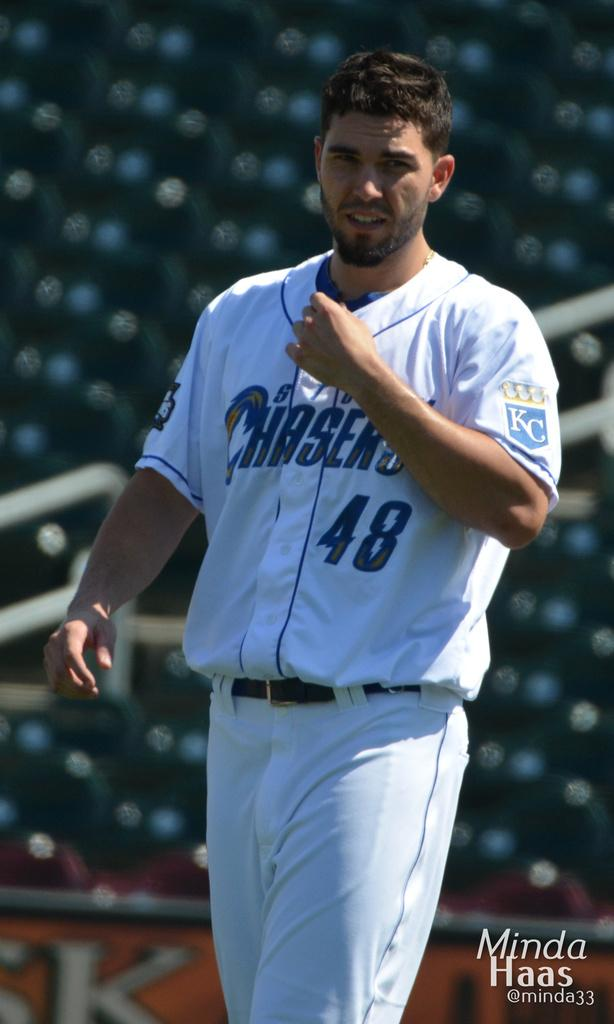<image>
Share a concise interpretation of the image provided. A baseball player number 48 is written on his uniform. 